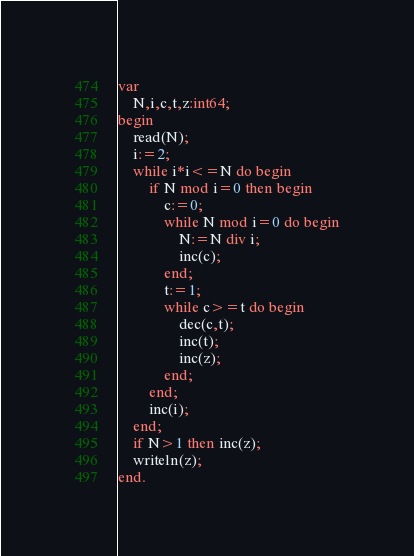Convert code to text. <code><loc_0><loc_0><loc_500><loc_500><_Pascal_>var
	N,i,c,t,z:int64;
begin
	read(N);
	i:=2;
	while i*i<=N do begin
		if N mod i=0 then begin
			c:=0;
			while N mod i=0 do begin
				N:=N div i;
				inc(c);
			end;
			t:=1;
			while c>=t do begin
				dec(c,t);
				inc(t);
				inc(z);
			end;
		end;
		inc(i);
	end;
	if N>1 then inc(z);
	writeln(z);
end.
</code> 